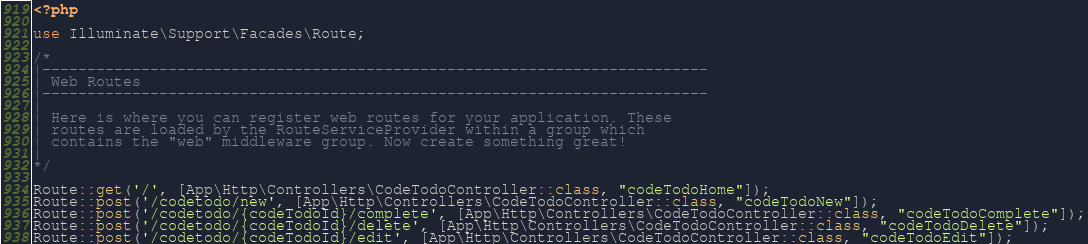Convert code to text. <code><loc_0><loc_0><loc_500><loc_500><_PHP_><?php

use Illuminate\Support\Facades\Route;

/*
|--------------------------------------------------------------------------
| Web Routes
|--------------------------------------------------------------------------
|
| Here is where you can register web routes for your application. These
| routes are loaded by the RouteServiceProvider within a group which
| contains the "web" middleware group. Now create something great!
|
*/

Route::get('/', [App\Http\Controllers\CodeTodoController::class, "codeTodoHome"]);
Route::post('/codetodo/new', [App\Http\Controllers\CodeTodoController::class, "codeTodoNew"]);
Route::post('/codetodo/{codeTodoId}/complete', [App\Http\Controllers\CodeTodoController::class, "codeTodoComplete"]);
Route::post('/codetodo/{codeTodoId}/delete', [App\Http\Controllers\CodeTodoController::class, "codeTodoDelete"]);
Route::post('/codetodo/{codeTodoId}/edit', [App\Http\Controllers\CodeTodoController::class, "codeTodoEdit"]);



</code> 